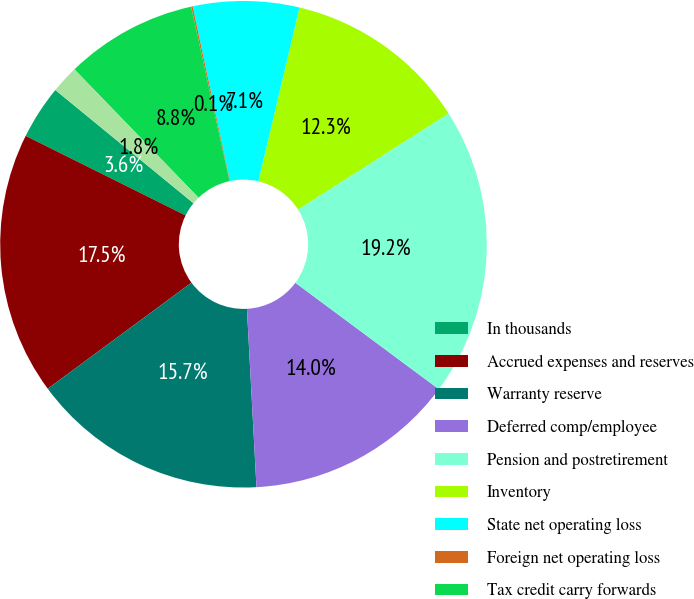Convert chart. <chart><loc_0><loc_0><loc_500><loc_500><pie_chart><fcel>In thousands<fcel>Accrued expenses and reserves<fcel>Warranty reserve<fcel>Deferred comp/employee<fcel>Pension and postretirement<fcel>Inventory<fcel>State net operating loss<fcel>Foreign net operating loss<fcel>Tax credit carry forwards<fcel>Other<nl><fcel>3.58%<fcel>17.47%<fcel>15.73%<fcel>13.99%<fcel>19.2%<fcel>12.26%<fcel>7.05%<fcel>0.1%<fcel>8.78%<fcel>1.84%<nl></chart> 